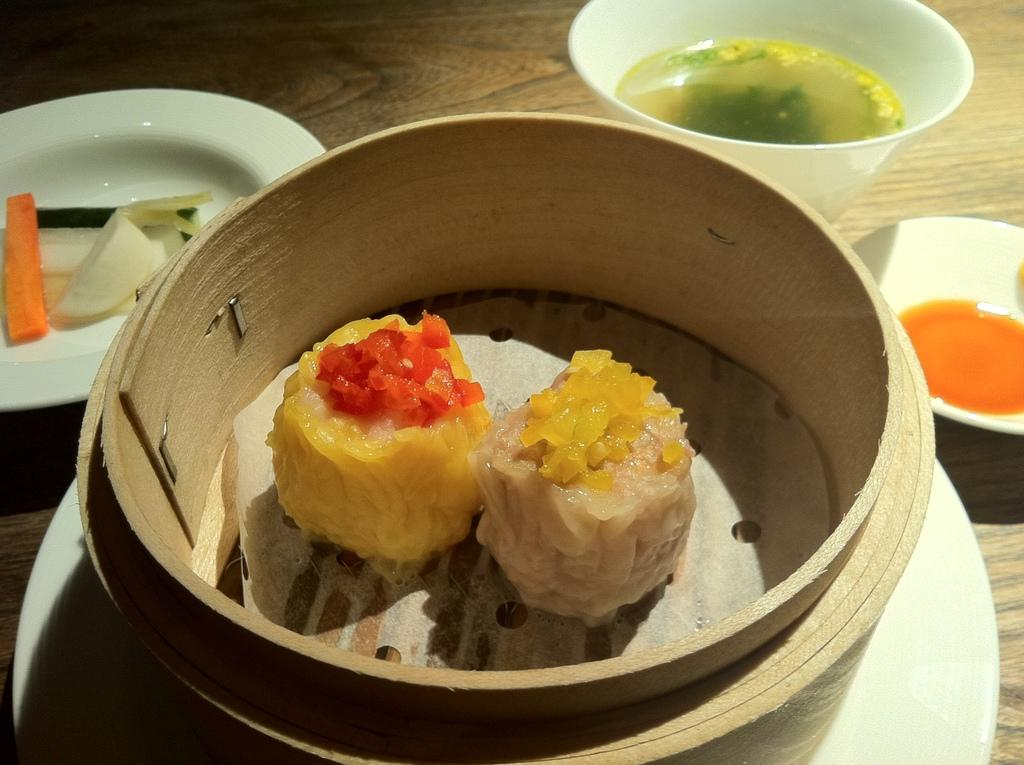What types of food can be seen in the image? There are food items, soups, and fruits in the image. What type of dishware is present in the image? There are plates and bowls in the image. What surface is visible in the image? The wooden surface is present in the image. Can you see the ocean in the image? No, the ocean is not present in the image. Is there a lamp visible in the image? No, there is no lamp present in the image. 